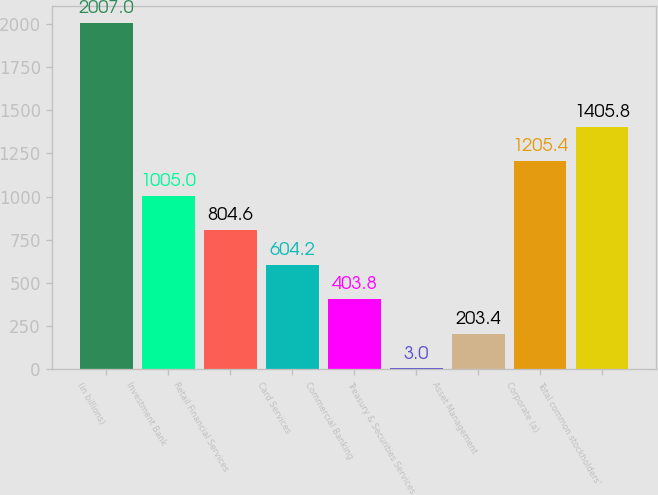Convert chart. <chart><loc_0><loc_0><loc_500><loc_500><bar_chart><fcel>(in billions)<fcel>Investment Bank<fcel>Retail Financial Services<fcel>Card Services<fcel>Commercial Banking<fcel>Treasury & Securities Services<fcel>Asset Management<fcel>Corporate (a)<fcel>Total common stockholders'<nl><fcel>2007<fcel>1005<fcel>804.6<fcel>604.2<fcel>403.8<fcel>3<fcel>203.4<fcel>1205.4<fcel>1405.8<nl></chart> 